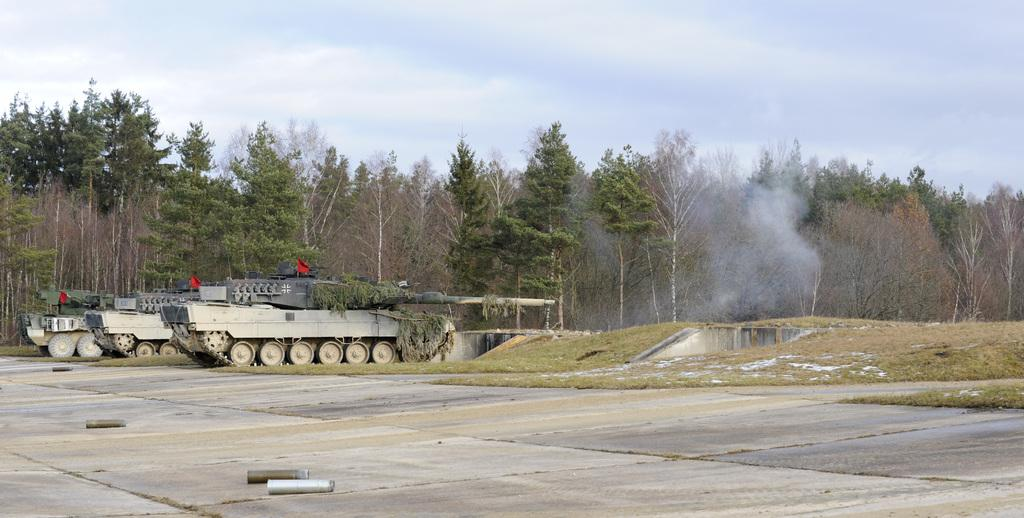What type of vehicles are in the image? There are military tankers in the image. What can be seen on the ground in the image? The ground is visible in the image, and there are objects on the ground. What type of vegetation is present in the image? Grass and trees are visible in the image. What is the condition of the sky in the image? The sky is visible in the image, and clouds are present in the sky. What is the result of the military tankers' activity in the image? There is smoke in the image as a result of the military tankers' activity. How many horses are pulling the military tankers in the image? There are no horses present in the image; the military tankers are not being pulled by any animals. 